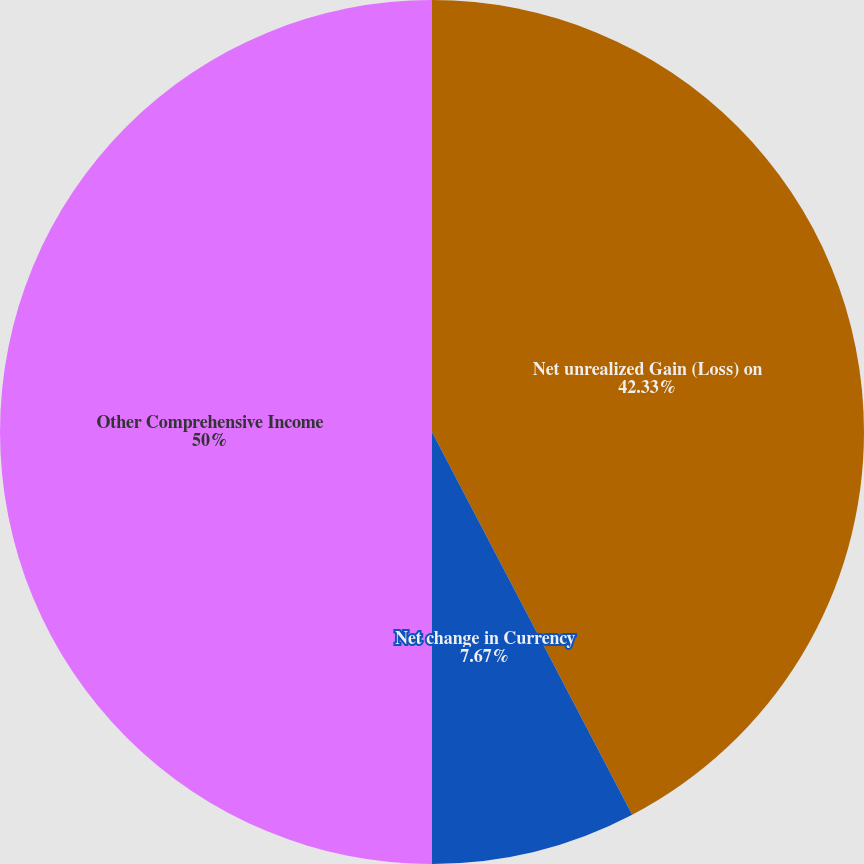<chart> <loc_0><loc_0><loc_500><loc_500><pie_chart><fcel>Net unrealized Gain (Loss) on<fcel>Net change in Currency<fcel>Other Comprehensive Income<nl><fcel>42.33%<fcel>7.67%<fcel>50.0%<nl></chart> 